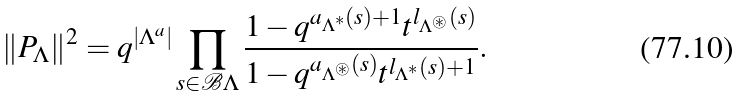<formula> <loc_0><loc_0><loc_500><loc_500>\| P _ { \Lambda } \| ^ { 2 } = q ^ { | \Lambda ^ { a } | } \prod _ { s \in \mathcal { B } \Lambda } \frac { 1 - q ^ { a _ { \Lambda ^ { * } } ( s ) + 1 } t ^ { l _ { \Lambda ^ { \circledast } } ( s ) } } { 1 - q ^ { a _ { \Lambda ^ { \circledast } } ( s ) } t ^ { l _ { \Lambda ^ { * } } ( s ) + 1 } } .</formula> 